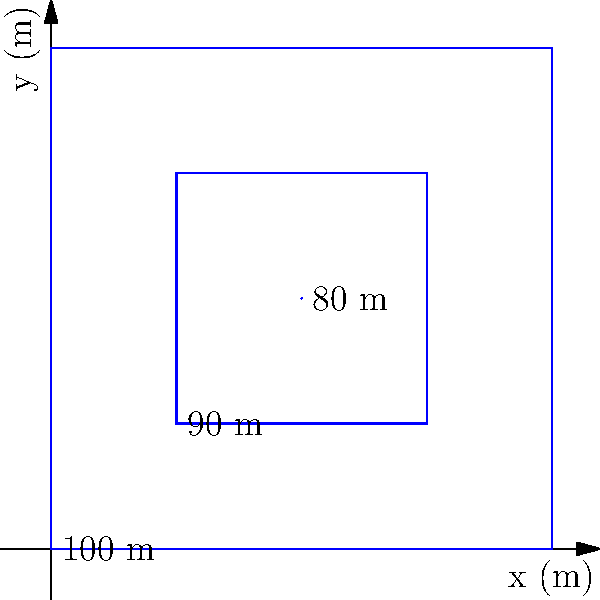A construction site needs to be excavated, and you have been provided with a topographic map showing contour lines. The map covers an area of 2m x 2m, with contour lines at 100m, 90m, and 80m elevations. If you need to excavate to the 80m level, what is the approximate volume of soil to be removed in cubic meters? To calculate the volume of an irregularly shaped excavation site using contour lines, we can use the average end area method. Here's a step-by-step approach:

1. Identify the contour areas:
   - 100m contour area: $A_1 = 2m \times 2m = 4m^2$
   - 90m contour area: $A_2 = 1m \times 1m = 1m^2$
   - 80m contour area: $A_3 = 0m^2$ (point)

2. Calculate the average areas between contours:
   - Between 100m and 90m: $\frac{A_1 + A_2}{2} = \frac{4m^2 + 1m^2}{2} = 2.5m^2$
   - Between 90m and 80m: $\frac{A_2 + A_3}{2} = \frac{1m^2 + 0m^2}{2} = 0.5m^2$

3. Multiply each average area by the height difference between contours (10m):
   - Volume 100m to 90m: $2.5m^2 \times 10m = 25m^3$
   - Volume 90m to 80m: $0.5m^2 \times 10m = 5m^3$

4. Sum the volumes:
   Total volume = $25m^3 + 5m^3 = 30m^3$

Therefore, the approximate volume of soil to be removed is 30 cubic meters.
Answer: $30m^3$ 